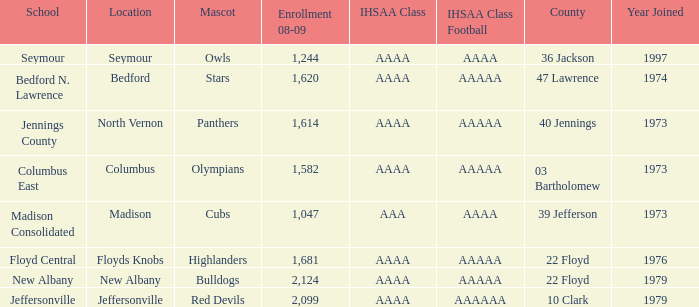What's the IHSAA Class Football if the panthers are the mascot? AAAAA. 